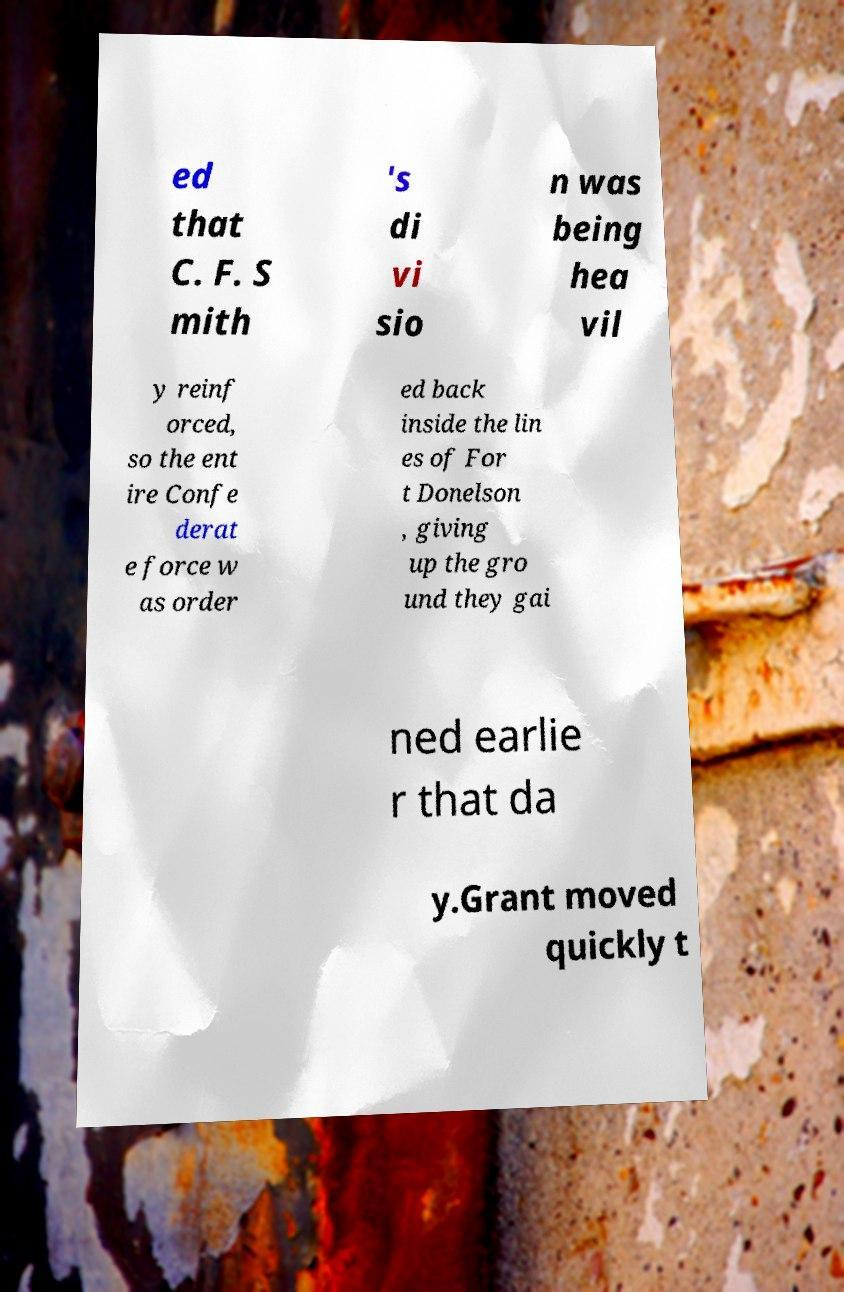Could you assist in decoding the text presented in this image and type it out clearly? ed that C. F. S mith 's di vi sio n was being hea vil y reinf orced, so the ent ire Confe derat e force w as order ed back inside the lin es of For t Donelson , giving up the gro und they gai ned earlie r that da y.Grant moved quickly t 